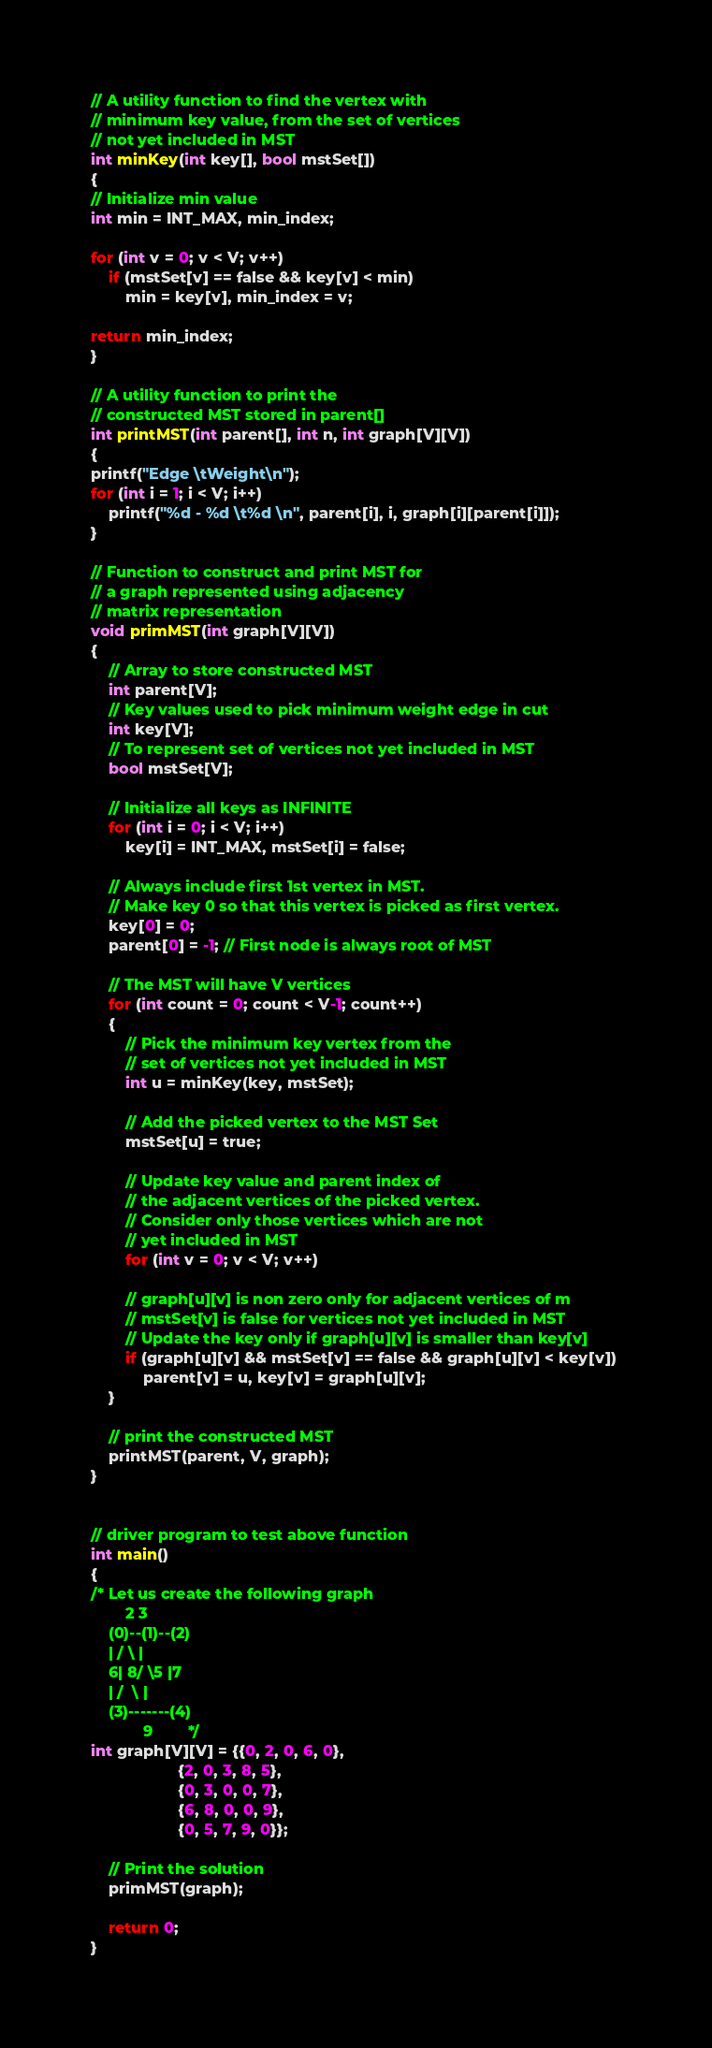Convert code to text. <code><loc_0><loc_0><loc_500><loc_500><_C++_>
// A utility function to find the vertex with 
// minimum key value, from the set of vertices 
// not yet included in MST 
int minKey(int key[], bool mstSet[]) 
{ 
// Initialize min value 
int min = INT_MAX, min_index; 

for (int v = 0; v < V; v++) 
	if (mstSet[v] == false && key[v] < min) 
		min = key[v], min_index = v; 

return min_index; 
} 

// A utility function to print the 
// constructed MST stored in parent[] 
int printMST(int parent[], int n, int graph[V][V]) 
{ 
printf("Edge \tWeight\n"); 
for (int i = 1; i < V; i++) 
	printf("%d - %d \t%d \n", parent[i], i, graph[i][parent[i]]); 
} 

// Function to construct and print MST for 
// a graph represented using adjacency 
// matrix representation 
void primMST(int graph[V][V]) 
{ 
	// Array to store constructed MST 
	int parent[V]; 
	// Key values used to pick minimum weight edge in cut 
	int key[V]; 
	// To represent set of vertices not yet included in MST 
	bool mstSet[V]; 

	// Initialize all keys as INFINITE 
	for (int i = 0; i < V; i++) 
		key[i] = INT_MAX, mstSet[i] = false; 

	// Always include first 1st vertex in MST. 
	// Make key 0 so that this vertex is picked as first vertex. 
	key[0] = 0;	 
	parent[0] = -1; // First node is always root of MST 

	// The MST will have V vertices 
	for (int count = 0; count < V-1; count++) 
	{ 
		// Pick the minimum key vertex from the 
		// set of vertices not yet included in MST 
		int u = minKey(key, mstSet); 

		// Add the picked vertex to the MST Set 
		mstSet[u] = true; 

		// Update key value and parent index of 
		// the adjacent vertices of the picked vertex. 
		// Consider only those vertices which are not 
		// yet included in MST 
		for (int v = 0; v < V; v++) 

		// graph[u][v] is non zero only for adjacent vertices of m 
		// mstSet[v] is false for vertices not yet included in MST 
		// Update the key only if graph[u][v] is smaller than key[v] 
		if (graph[u][v] && mstSet[v] == false && graph[u][v] < key[v]) 
			parent[v] = u, key[v] = graph[u][v]; 
	} 

	// print the constructed MST 
	printMST(parent, V, graph); 
} 


// driver program to test above function 
int main() 
{ 
/* Let us create the following graph 
		2 3 
	(0)--(1)--(2) 
	| / \ | 
	6| 8/ \5 |7 
	| /	 \ | 
	(3)-------(4) 
			9		 */
int graph[V][V] = {{0, 2, 0, 6, 0}, 
					{2, 0, 3, 8, 5}, 
					{0, 3, 0, 0, 7}, 
					{6, 8, 0, 0, 9}, 
					{0, 5, 7, 9, 0}}; 

	// Print the solution 
	primMST(graph); 

	return 0; 
} </code> 